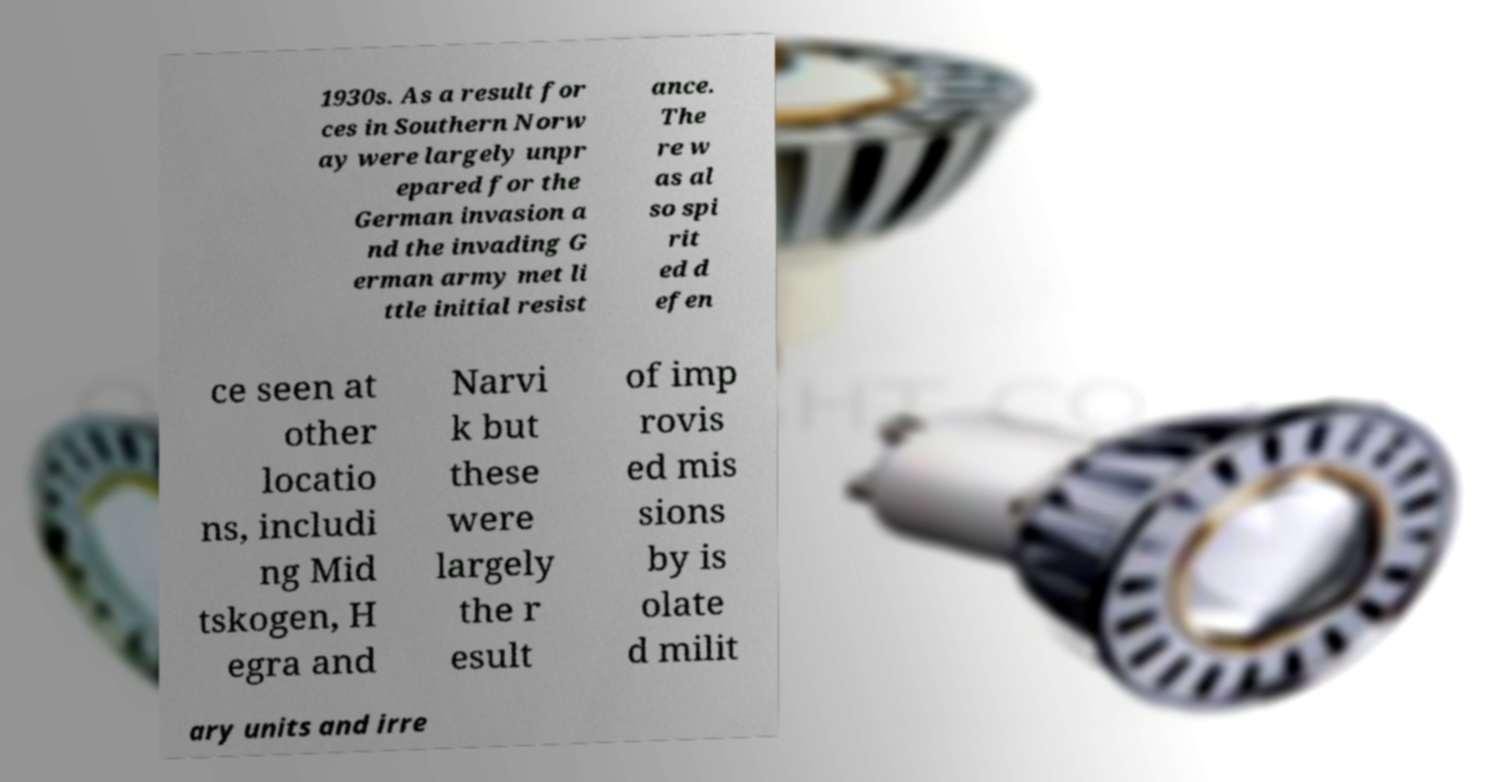What messages or text are displayed in this image? I need them in a readable, typed format. 1930s. As a result for ces in Southern Norw ay were largely unpr epared for the German invasion a nd the invading G erman army met li ttle initial resist ance. The re w as al so spi rit ed d efen ce seen at other locatio ns, includi ng Mid tskogen, H egra and Narvi k but these were largely the r esult of imp rovis ed mis sions by is olate d milit ary units and irre 